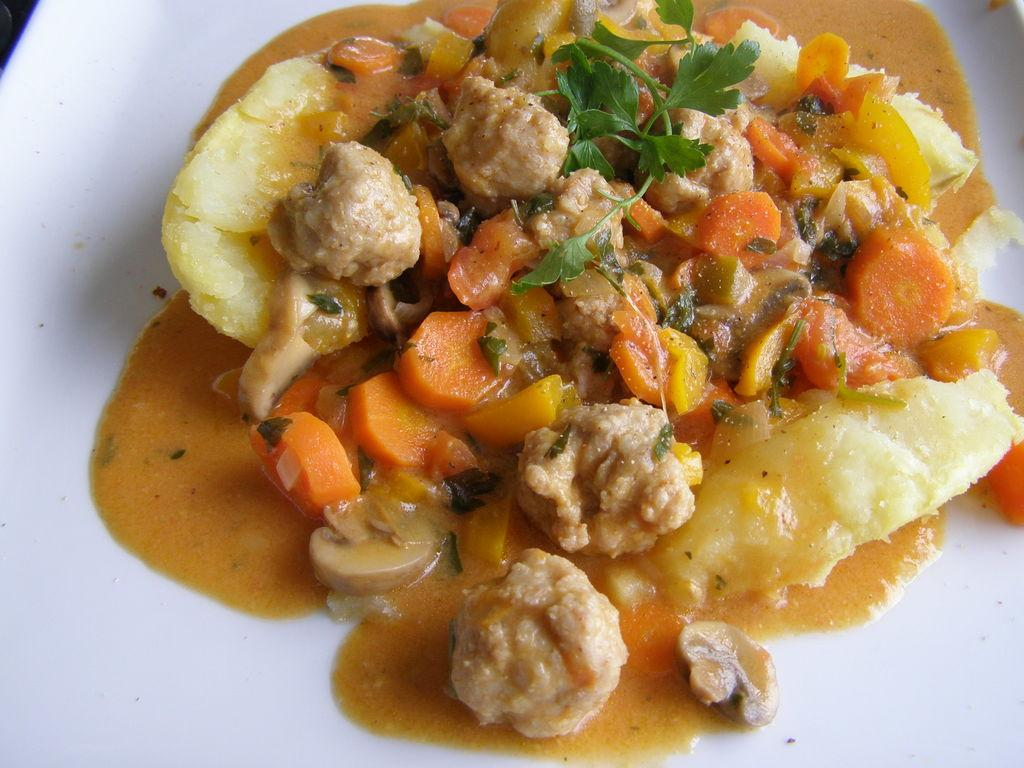What is in the food dish that is visible in the image? The food dish contains carrot pieces and coriander leaves. What color is the plate in the image? The plate is white. How many teeth can be seen in the image? There are no teeth visible in the image. What type of butter is being used in the dish in the image? There is no butter present in the image; it contains carrot pieces and coriander leaves. 